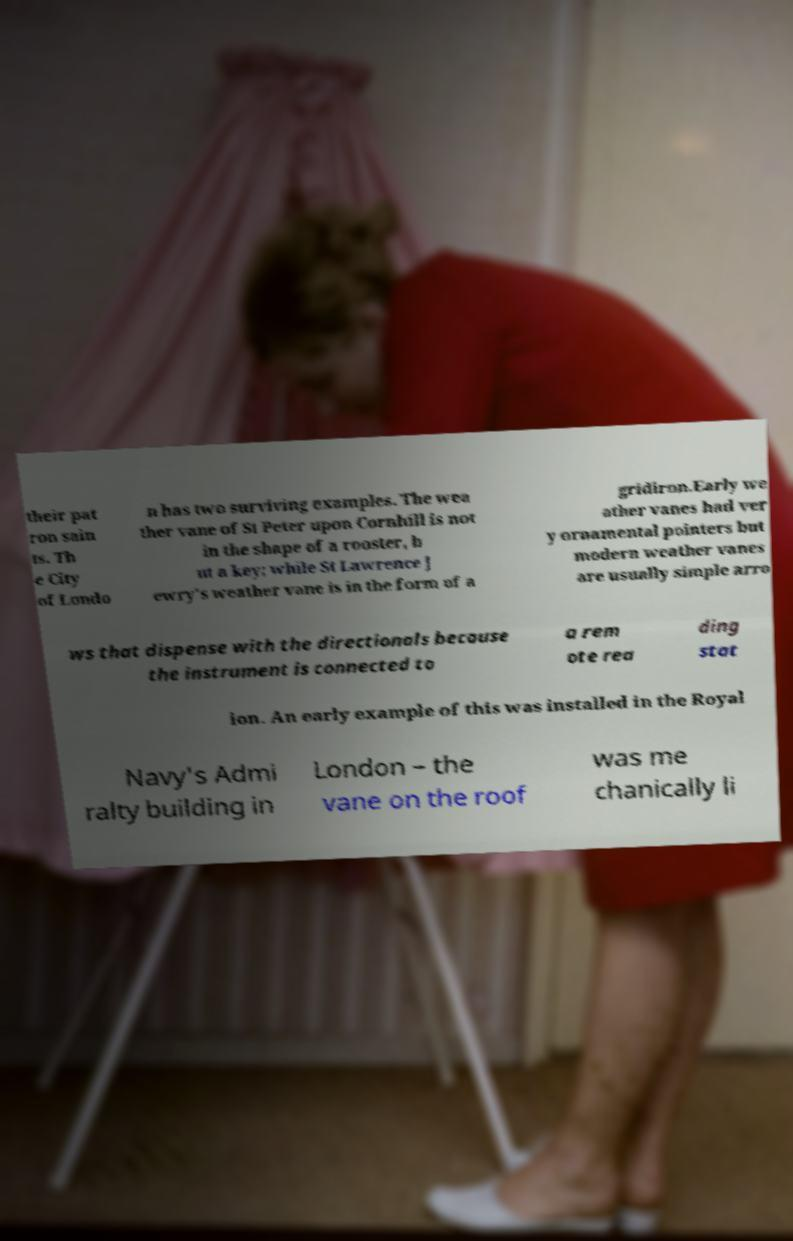Could you extract and type out the text from this image? their pat ron sain ts. Th e City of Londo n has two surviving examples. The wea ther vane of St Peter upon Cornhill is not in the shape of a rooster, b ut a key; while St Lawrence J ewry's weather vane is in the form of a gridiron.Early we ather vanes had ver y ornamental pointers but modern weather vanes are usually simple arro ws that dispense with the directionals because the instrument is connected to a rem ote rea ding stat ion. An early example of this was installed in the Royal Navy's Admi ralty building in London – the vane on the roof was me chanically li 